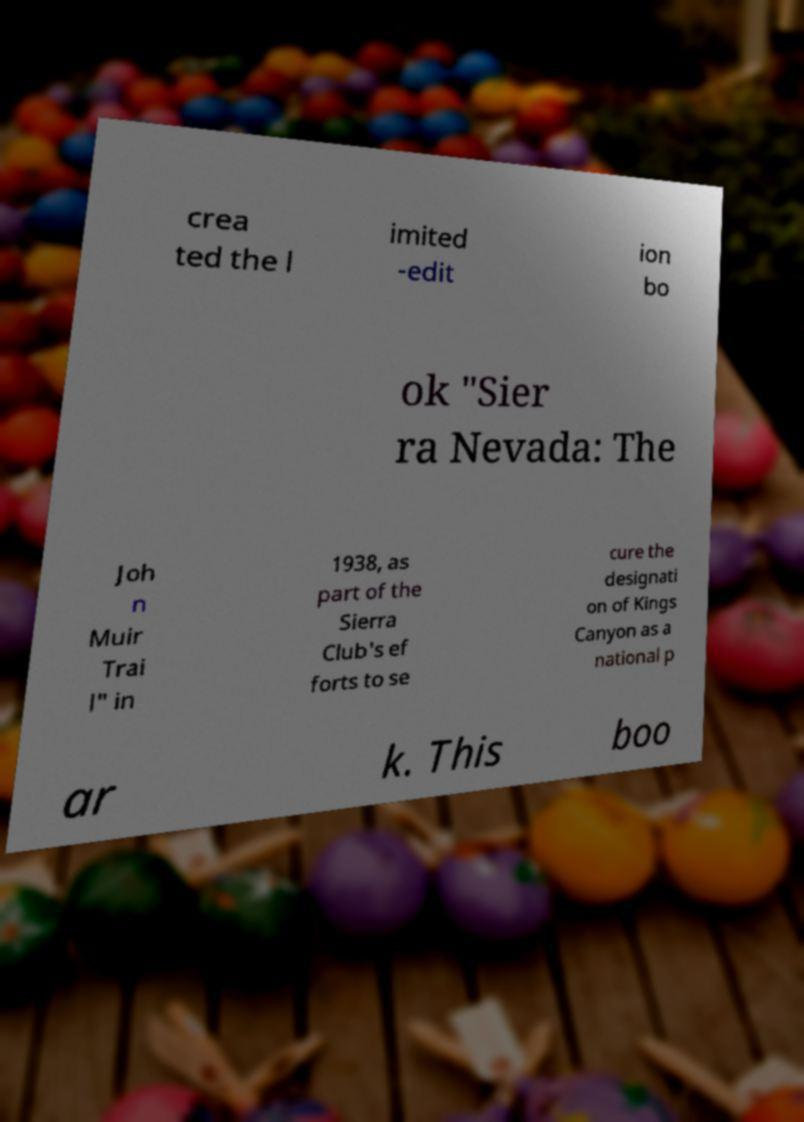What messages or text are displayed in this image? I need them in a readable, typed format. crea ted the l imited -edit ion bo ok "Sier ra Nevada: The Joh n Muir Trai l" in 1938, as part of the Sierra Club's ef forts to se cure the designati on of Kings Canyon as a national p ar k. This boo 